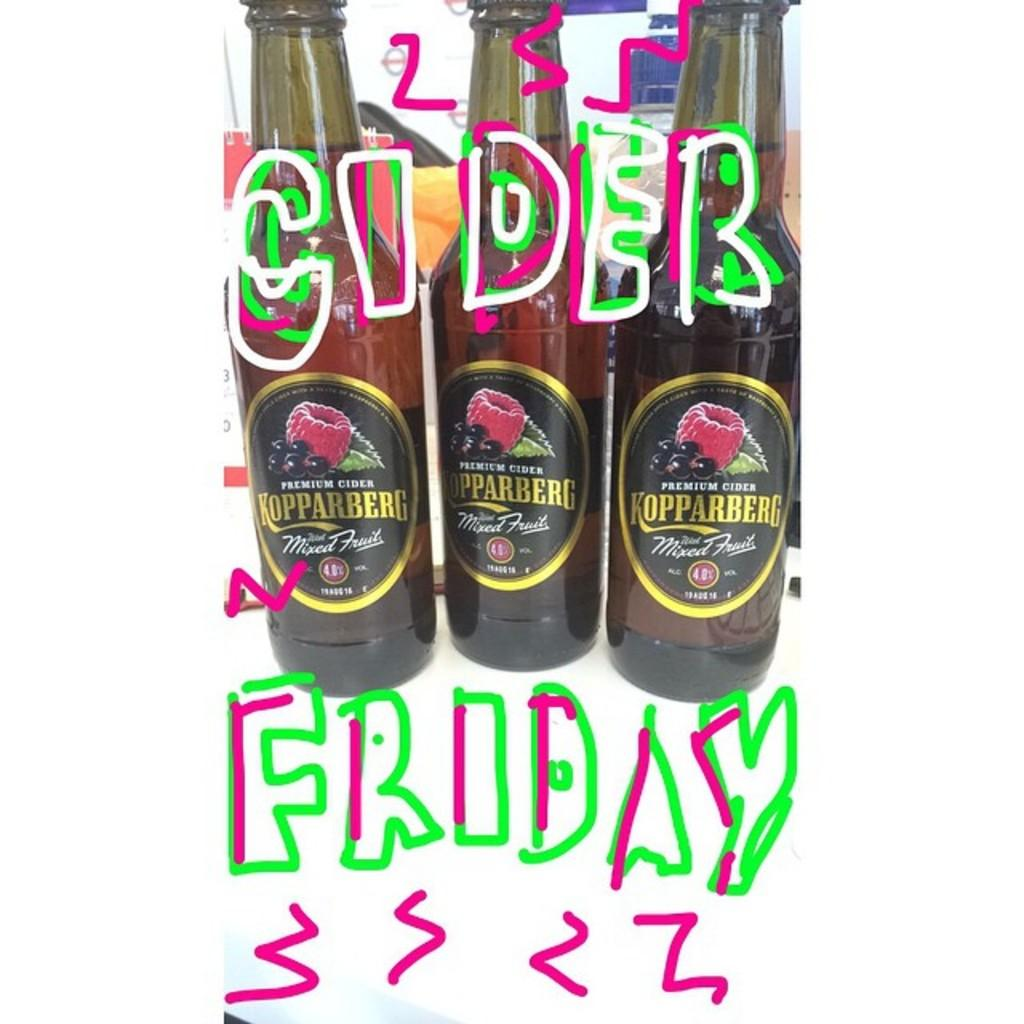<image>
Offer a succinct explanation of the picture presented. A photo that says Cider Friday with three bottle of cider. 